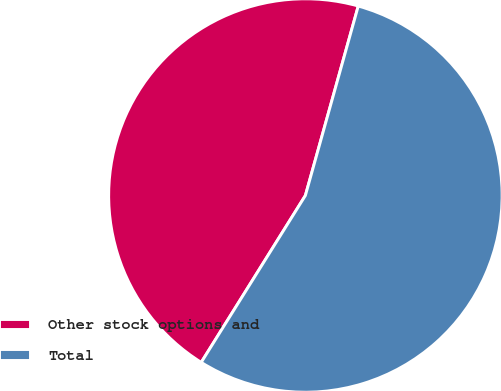Convert chart to OTSL. <chart><loc_0><loc_0><loc_500><loc_500><pie_chart><fcel>Other stock options and<fcel>Total<nl><fcel>45.45%<fcel>54.55%<nl></chart> 